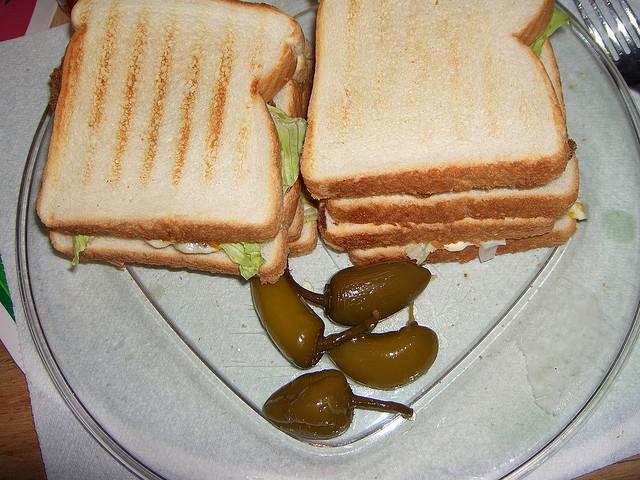How many slices of bread are here?
Give a very brief answer. 8. How many sandwiches are there?
Give a very brief answer. 2. How many people are in front of the tables?
Give a very brief answer. 0. 